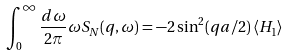<formula> <loc_0><loc_0><loc_500><loc_500>\int _ { 0 } ^ { \infty } \frac { d \omega } { 2 \pi } \omega S _ { N } ( q , \omega ) = - 2 \sin ^ { 2 } ( q a / 2 ) \left \langle H _ { 1 } \right \rangle</formula> 